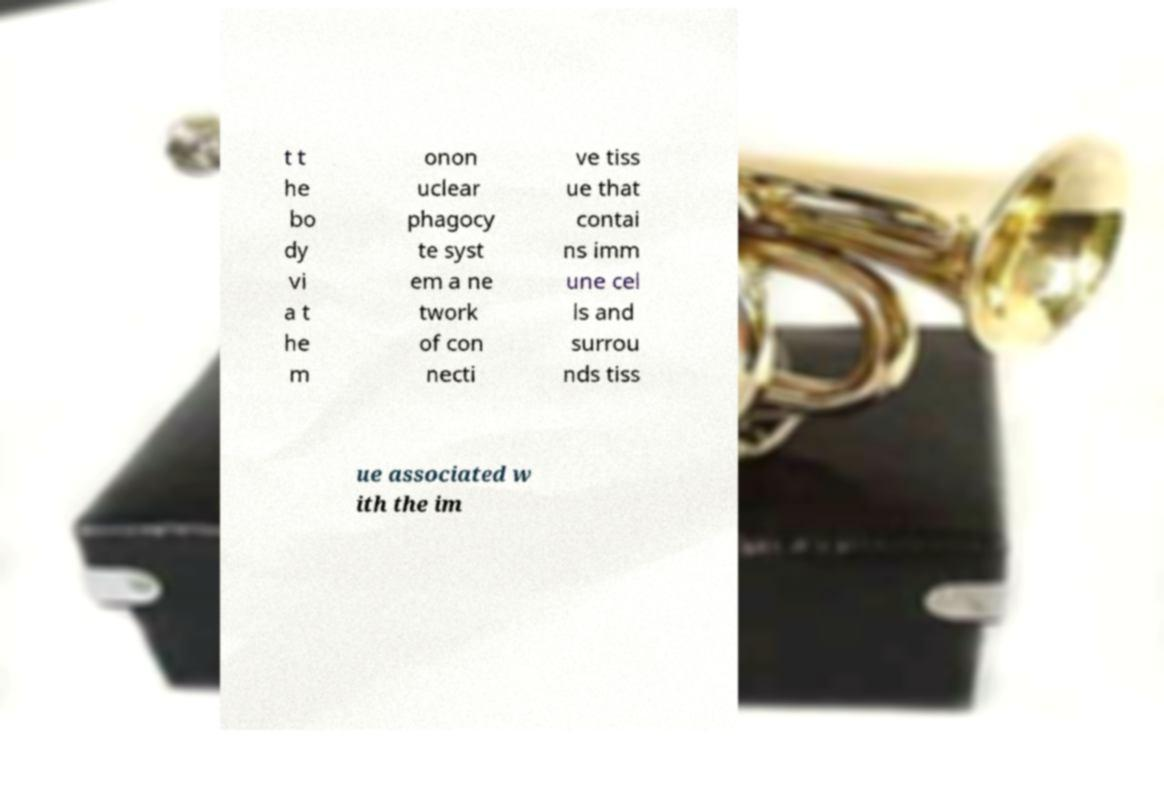I need the written content from this picture converted into text. Can you do that? t t he bo dy vi a t he m onon uclear phagocy te syst em a ne twork of con necti ve tiss ue that contai ns imm une cel ls and surrou nds tiss ue associated w ith the im 